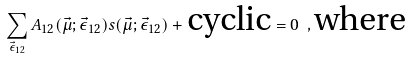<formula> <loc_0><loc_0><loc_500><loc_500>\sum _ { \vec { \epsilon } _ { 1 2 } } A _ { 1 2 } ( \vec { \mu } ; \vec { \epsilon } _ { 1 2 } ) s ( \vec { \mu } ; \vec { \epsilon } _ { 1 2 } ) + \text {cyclic} = 0 \ , \text {where}</formula> 